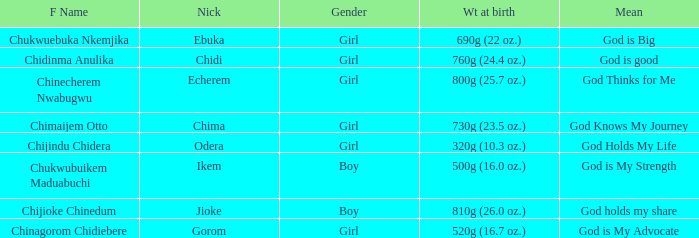What nickname has the meaning of God knows my journey? Chima. 